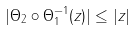Convert formula to latex. <formula><loc_0><loc_0><loc_500><loc_500>| \Theta _ { 2 } \circ \Theta _ { 1 } ^ { - 1 } ( z ) | \leq | z |</formula> 